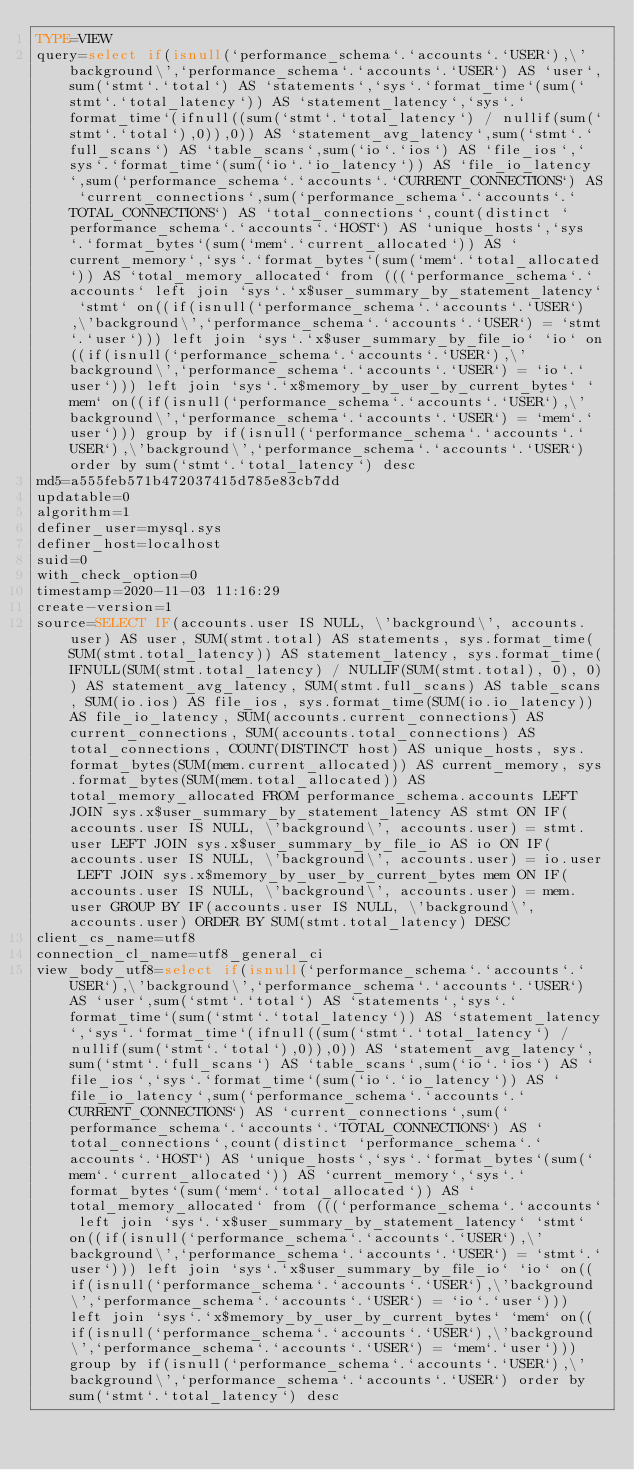<code> <loc_0><loc_0><loc_500><loc_500><_VisualBasic_>TYPE=VIEW
query=select if(isnull(`performance_schema`.`accounts`.`USER`),\'background\',`performance_schema`.`accounts`.`USER`) AS `user`,sum(`stmt`.`total`) AS `statements`,`sys`.`format_time`(sum(`stmt`.`total_latency`)) AS `statement_latency`,`sys`.`format_time`(ifnull((sum(`stmt`.`total_latency`) / nullif(sum(`stmt`.`total`),0)),0)) AS `statement_avg_latency`,sum(`stmt`.`full_scans`) AS `table_scans`,sum(`io`.`ios`) AS `file_ios`,`sys`.`format_time`(sum(`io`.`io_latency`)) AS `file_io_latency`,sum(`performance_schema`.`accounts`.`CURRENT_CONNECTIONS`) AS `current_connections`,sum(`performance_schema`.`accounts`.`TOTAL_CONNECTIONS`) AS `total_connections`,count(distinct `performance_schema`.`accounts`.`HOST`) AS `unique_hosts`,`sys`.`format_bytes`(sum(`mem`.`current_allocated`)) AS `current_memory`,`sys`.`format_bytes`(sum(`mem`.`total_allocated`)) AS `total_memory_allocated` from (((`performance_schema`.`accounts` left join `sys`.`x$user_summary_by_statement_latency` `stmt` on((if(isnull(`performance_schema`.`accounts`.`USER`),\'background\',`performance_schema`.`accounts`.`USER`) = `stmt`.`user`))) left join `sys`.`x$user_summary_by_file_io` `io` on((if(isnull(`performance_schema`.`accounts`.`USER`),\'background\',`performance_schema`.`accounts`.`USER`) = `io`.`user`))) left join `sys`.`x$memory_by_user_by_current_bytes` `mem` on((if(isnull(`performance_schema`.`accounts`.`USER`),\'background\',`performance_schema`.`accounts`.`USER`) = `mem`.`user`))) group by if(isnull(`performance_schema`.`accounts`.`USER`),\'background\',`performance_schema`.`accounts`.`USER`) order by sum(`stmt`.`total_latency`) desc
md5=a555feb571b472037415d785e83cb7dd
updatable=0
algorithm=1
definer_user=mysql.sys
definer_host=localhost
suid=0
with_check_option=0
timestamp=2020-11-03 11:16:29
create-version=1
source=SELECT IF(accounts.user IS NULL, \'background\', accounts.user) AS user, SUM(stmt.total) AS statements, sys.format_time(SUM(stmt.total_latency)) AS statement_latency, sys.format_time(IFNULL(SUM(stmt.total_latency) / NULLIF(SUM(stmt.total), 0), 0)) AS statement_avg_latency, SUM(stmt.full_scans) AS table_scans, SUM(io.ios) AS file_ios, sys.format_time(SUM(io.io_latency)) AS file_io_latency, SUM(accounts.current_connections) AS current_connections, SUM(accounts.total_connections) AS total_connections, COUNT(DISTINCT host) AS unique_hosts, sys.format_bytes(SUM(mem.current_allocated)) AS current_memory, sys.format_bytes(SUM(mem.total_allocated)) AS total_memory_allocated FROM performance_schema.accounts LEFT JOIN sys.x$user_summary_by_statement_latency AS stmt ON IF(accounts.user IS NULL, \'background\', accounts.user) = stmt.user LEFT JOIN sys.x$user_summary_by_file_io AS io ON IF(accounts.user IS NULL, \'background\', accounts.user) = io.user LEFT JOIN sys.x$memory_by_user_by_current_bytes mem ON IF(accounts.user IS NULL, \'background\', accounts.user) = mem.user GROUP BY IF(accounts.user IS NULL, \'background\', accounts.user) ORDER BY SUM(stmt.total_latency) DESC
client_cs_name=utf8
connection_cl_name=utf8_general_ci
view_body_utf8=select if(isnull(`performance_schema`.`accounts`.`USER`),\'background\',`performance_schema`.`accounts`.`USER`) AS `user`,sum(`stmt`.`total`) AS `statements`,`sys`.`format_time`(sum(`stmt`.`total_latency`)) AS `statement_latency`,`sys`.`format_time`(ifnull((sum(`stmt`.`total_latency`) / nullif(sum(`stmt`.`total`),0)),0)) AS `statement_avg_latency`,sum(`stmt`.`full_scans`) AS `table_scans`,sum(`io`.`ios`) AS `file_ios`,`sys`.`format_time`(sum(`io`.`io_latency`)) AS `file_io_latency`,sum(`performance_schema`.`accounts`.`CURRENT_CONNECTIONS`) AS `current_connections`,sum(`performance_schema`.`accounts`.`TOTAL_CONNECTIONS`) AS `total_connections`,count(distinct `performance_schema`.`accounts`.`HOST`) AS `unique_hosts`,`sys`.`format_bytes`(sum(`mem`.`current_allocated`)) AS `current_memory`,`sys`.`format_bytes`(sum(`mem`.`total_allocated`)) AS `total_memory_allocated` from (((`performance_schema`.`accounts` left join `sys`.`x$user_summary_by_statement_latency` `stmt` on((if(isnull(`performance_schema`.`accounts`.`USER`),\'background\',`performance_schema`.`accounts`.`USER`) = `stmt`.`user`))) left join `sys`.`x$user_summary_by_file_io` `io` on((if(isnull(`performance_schema`.`accounts`.`USER`),\'background\',`performance_schema`.`accounts`.`USER`) = `io`.`user`))) left join `sys`.`x$memory_by_user_by_current_bytes` `mem` on((if(isnull(`performance_schema`.`accounts`.`USER`),\'background\',`performance_schema`.`accounts`.`USER`) = `mem`.`user`))) group by if(isnull(`performance_schema`.`accounts`.`USER`),\'background\',`performance_schema`.`accounts`.`USER`) order by sum(`stmt`.`total_latency`) desc
</code> 